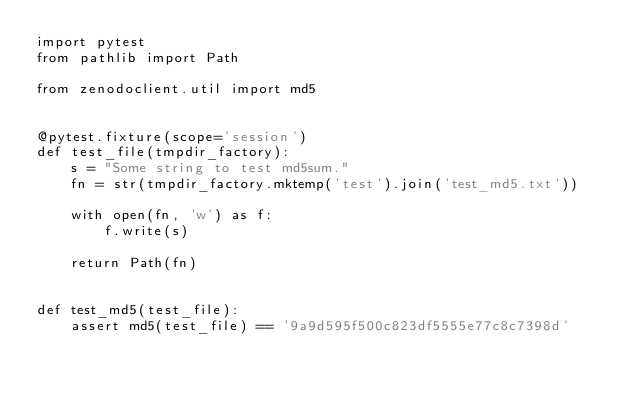Convert code to text. <code><loc_0><loc_0><loc_500><loc_500><_Python_>import pytest
from pathlib import Path

from zenodoclient.util import md5


@pytest.fixture(scope='session')
def test_file(tmpdir_factory):
    s = "Some string to test md5sum."
    fn = str(tmpdir_factory.mktemp('test').join('test_md5.txt'))

    with open(fn, 'w') as f:
        f.write(s)

    return Path(fn)


def test_md5(test_file):
    assert md5(test_file) == '9a9d595f500c823df5555e77c8c7398d'
</code> 